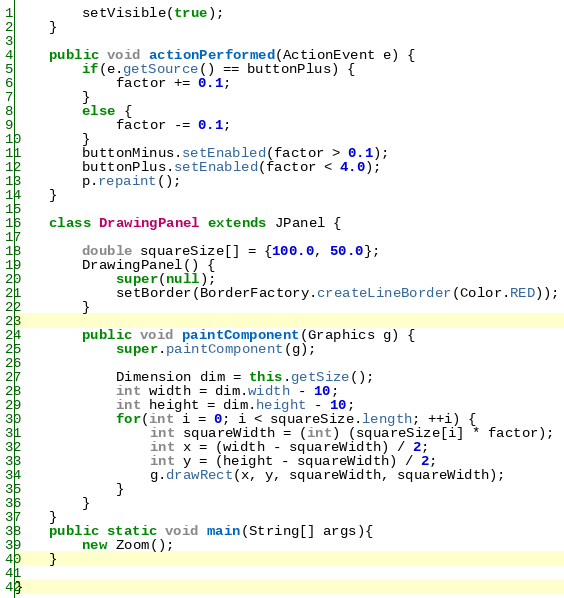Convert code to text. <code><loc_0><loc_0><loc_500><loc_500><_Java_>		setVisible(true);
	}

	public void actionPerformed(ActionEvent e) {
		if(e.getSource() == buttonPlus) {
			factor += 0.1;
		}
		else {
			factor -= 0.1;
		}
		buttonMinus.setEnabled(factor > 0.1);
		buttonPlus.setEnabled(factor < 4.0);
		p.repaint();
	}

	class DrawingPanel extends JPanel {

		double squareSize[] = {100.0, 50.0};
		DrawingPanel() {
			super(null);
			setBorder(BorderFactory.createLineBorder(Color.RED));
		}

		public void paintComponent(Graphics g) {
			super.paintComponent(g);

			Dimension dim = this.getSize();
			int width = dim.width - 10;
			int height = dim.height - 10;
			for(int i = 0; i < squareSize.length; ++i) {
				int squareWidth = (int) (squareSize[i] * factor);
				int x = (width - squareWidth) / 2;
				int y = (height - squareWidth) / 2;
				g.drawRect(x, y, squareWidth, squareWidth);
			}
		}
	}
	public static void main(String[] args){
		new Zoom();
	}

}
</code> 